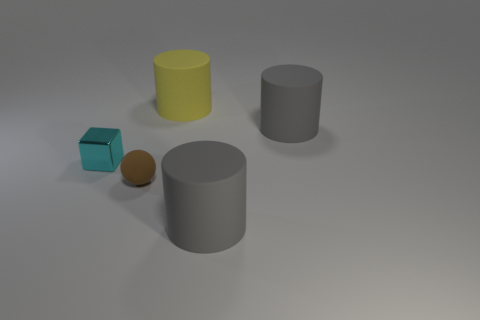Is there any other thing that is made of the same material as the tiny cyan object?
Your answer should be very brief. No. There is a matte thing to the left of the large yellow cylinder; how many tiny spheres are in front of it?
Ensure brevity in your answer.  0. There is a small rubber thing; is its color the same as the small thing behind the tiny brown sphere?
Make the answer very short. No. There is a metal object that is the same size as the brown rubber object; what is its color?
Keep it short and to the point. Cyan. Is there a big yellow thing of the same shape as the tiny cyan shiny thing?
Keep it short and to the point. No. Are there fewer large yellow objects than brown metallic blocks?
Provide a short and direct response. No. The big cylinder that is in front of the tiny brown rubber thing is what color?
Provide a succinct answer. Gray. The small object that is on the left side of the small object that is to the right of the tiny cyan object is what shape?
Give a very brief answer. Cube. Does the small cyan cube have the same material as the gray object that is behind the cyan metal block?
Make the answer very short. No. How many things have the same size as the yellow cylinder?
Ensure brevity in your answer.  2. 